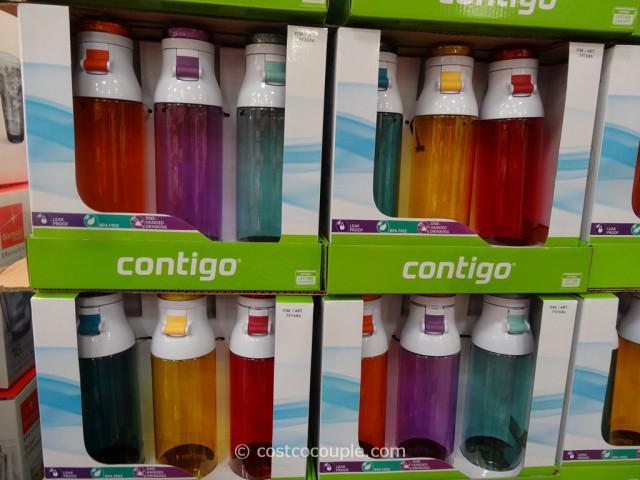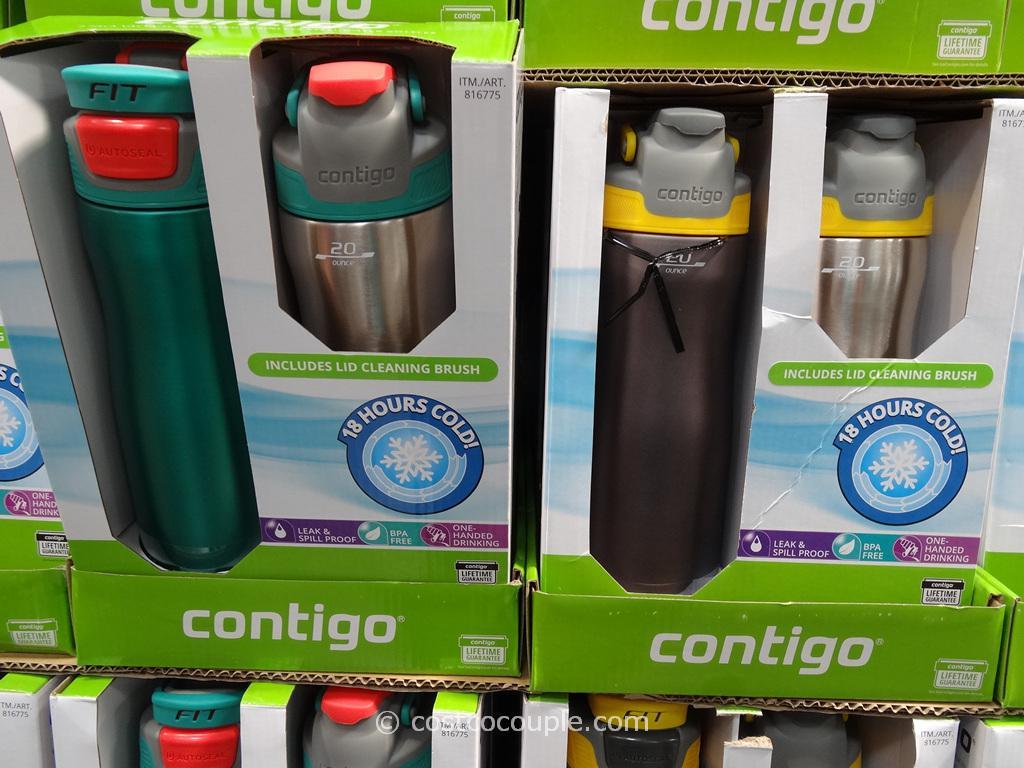The first image is the image on the left, the second image is the image on the right. Considering the images on both sides, is "A package showing three different colors of water bottles features a trio of blue, violet and hot pink hexagon shapes on the bottom front of the box." valid? Answer yes or no. No. The first image is the image on the left, the second image is the image on the right. Analyze the images presented: Is the assertion "A stainless steel water bottle is next to a green water bottle." valid? Answer yes or no. Yes. 